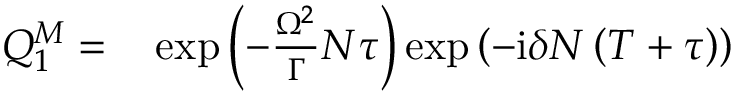<formula> <loc_0><loc_0><loc_500><loc_500>\begin{array} { r l } { Q _ { 1 } ^ { M } = } & \exp \left ( - \frac { \Omega ^ { 2 } } { \Gamma } N \tau \right ) \exp \left ( - i \delta N \left ( T + \tau \right ) \right ) } \end{array}</formula> 